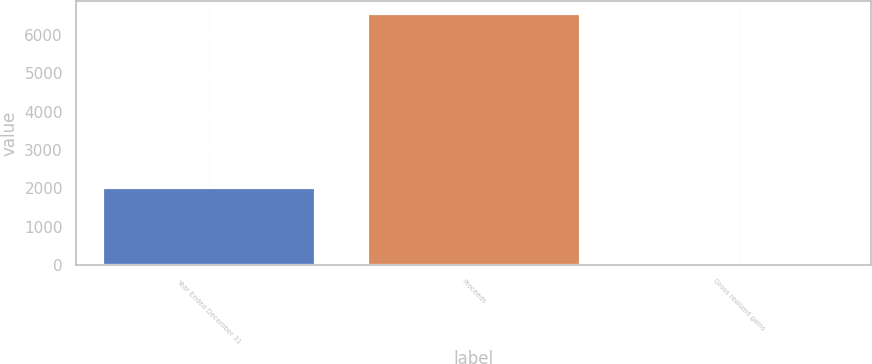Convert chart to OTSL. <chart><loc_0><loc_0><loc_500><loc_500><bar_chart><fcel>Year Ended December 31<fcel>Proceeds<fcel>Gross realized gains<nl><fcel>2014<fcel>6556<fcel>30<nl></chart> 